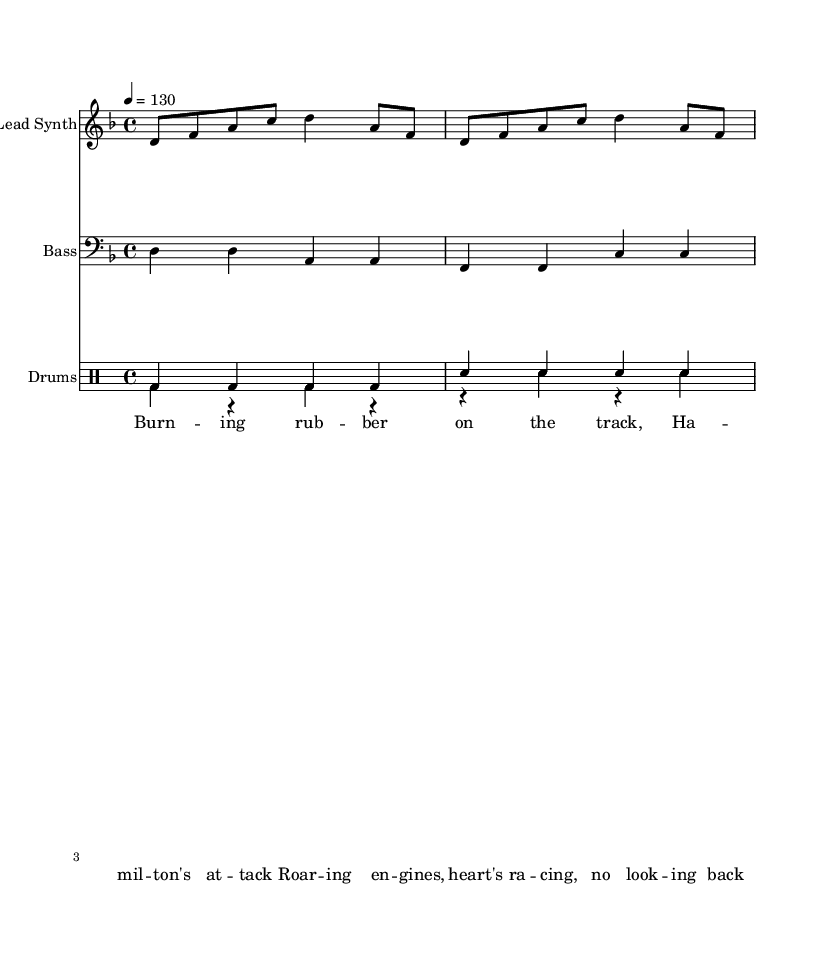What is the time signature of this music? The time signature is indicated as 4/4, which can be found at the beginning of the score. It shows that each measure has four beats, with each beat being a quarter note.
Answer: 4/4 What is the key signature of this music? The key signature is indicated as D minor, which has one flat (B flat) and is determined by the position of the notes and the key indicated at the start of the score.
Answer: D minor What is the tempo marking for this piece? The tempo marking is shown as 4 = 130, which signifies that there are 130 beats per minute, indicating the speed at which the music should be played.
Answer: 130 How many measures are in the lead synth part? The lead synth part consists of two repeated measures, making a total of 4 measures when played in the repeated section indicated by the notes.
Answer: 4 What is the main theme of the lyrics provided? The lyrics focus on racing, specifically featuring a reference to Hamilton and the excitement of burning rubber on the track, which encapsulates the thrill of Formula 1 racing.
Answer: Racing What instruments are featured in this sheet music? The instruments listed in the score include Lead Synth, Bass, and Drums, each with their own staff noted at the beginning.
Answer: Lead Synth, Bass, Drums What type of music style is this piece categorized as? This piece is categorized as Rap, which is indicated by the lyrical style and the energetic rhythm suitable for hip-hop anthems related to Formula 1 racing.
Answer: Rap 